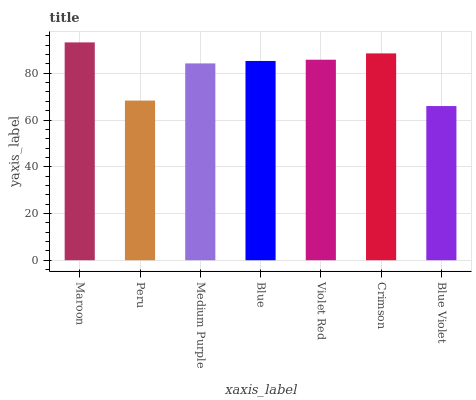Is Blue Violet the minimum?
Answer yes or no. Yes. Is Maroon the maximum?
Answer yes or no. Yes. Is Peru the minimum?
Answer yes or no. No. Is Peru the maximum?
Answer yes or no. No. Is Maroon greater than Peru?
Answer yes or no. Yes. Is Peru less than Maroon?
Answer yes or no. Yes. Is Peru greater than Maroon?
Answer yes or no. No. Is Maroon less than Peru?
Answer yes or no. No. Is Blue the high median?
Answer yes or no. Yes. Is Blue the low median?
Answer yes or no. Yes. Is Medium Purple the high median?
Answer yes or no. No. Is Crimson the low median?
Answer yes or no. No. 